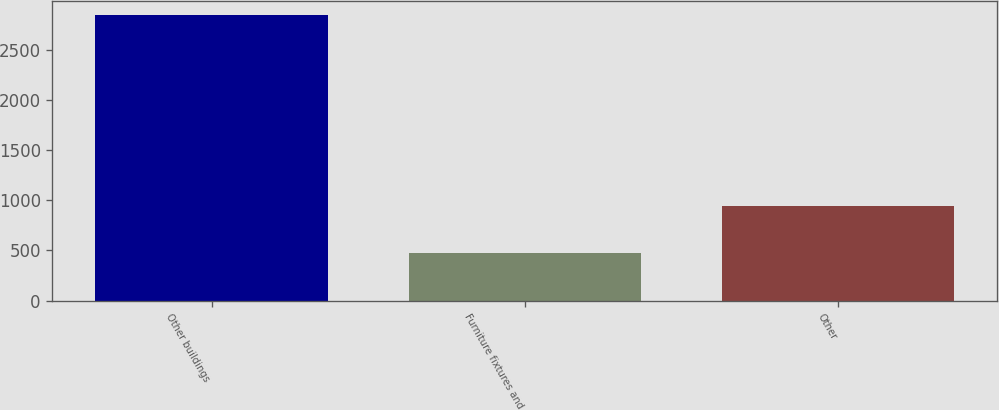Convert chart to OTSL. <chart><loc_0><loc_0><loc_500><loc_500><bar_chart><fcel>Other buildings<fcel>Furniture fixtures and<fcel>Other<nl><fcel>2840<fcel>472<fcel>939<nl></chart> 